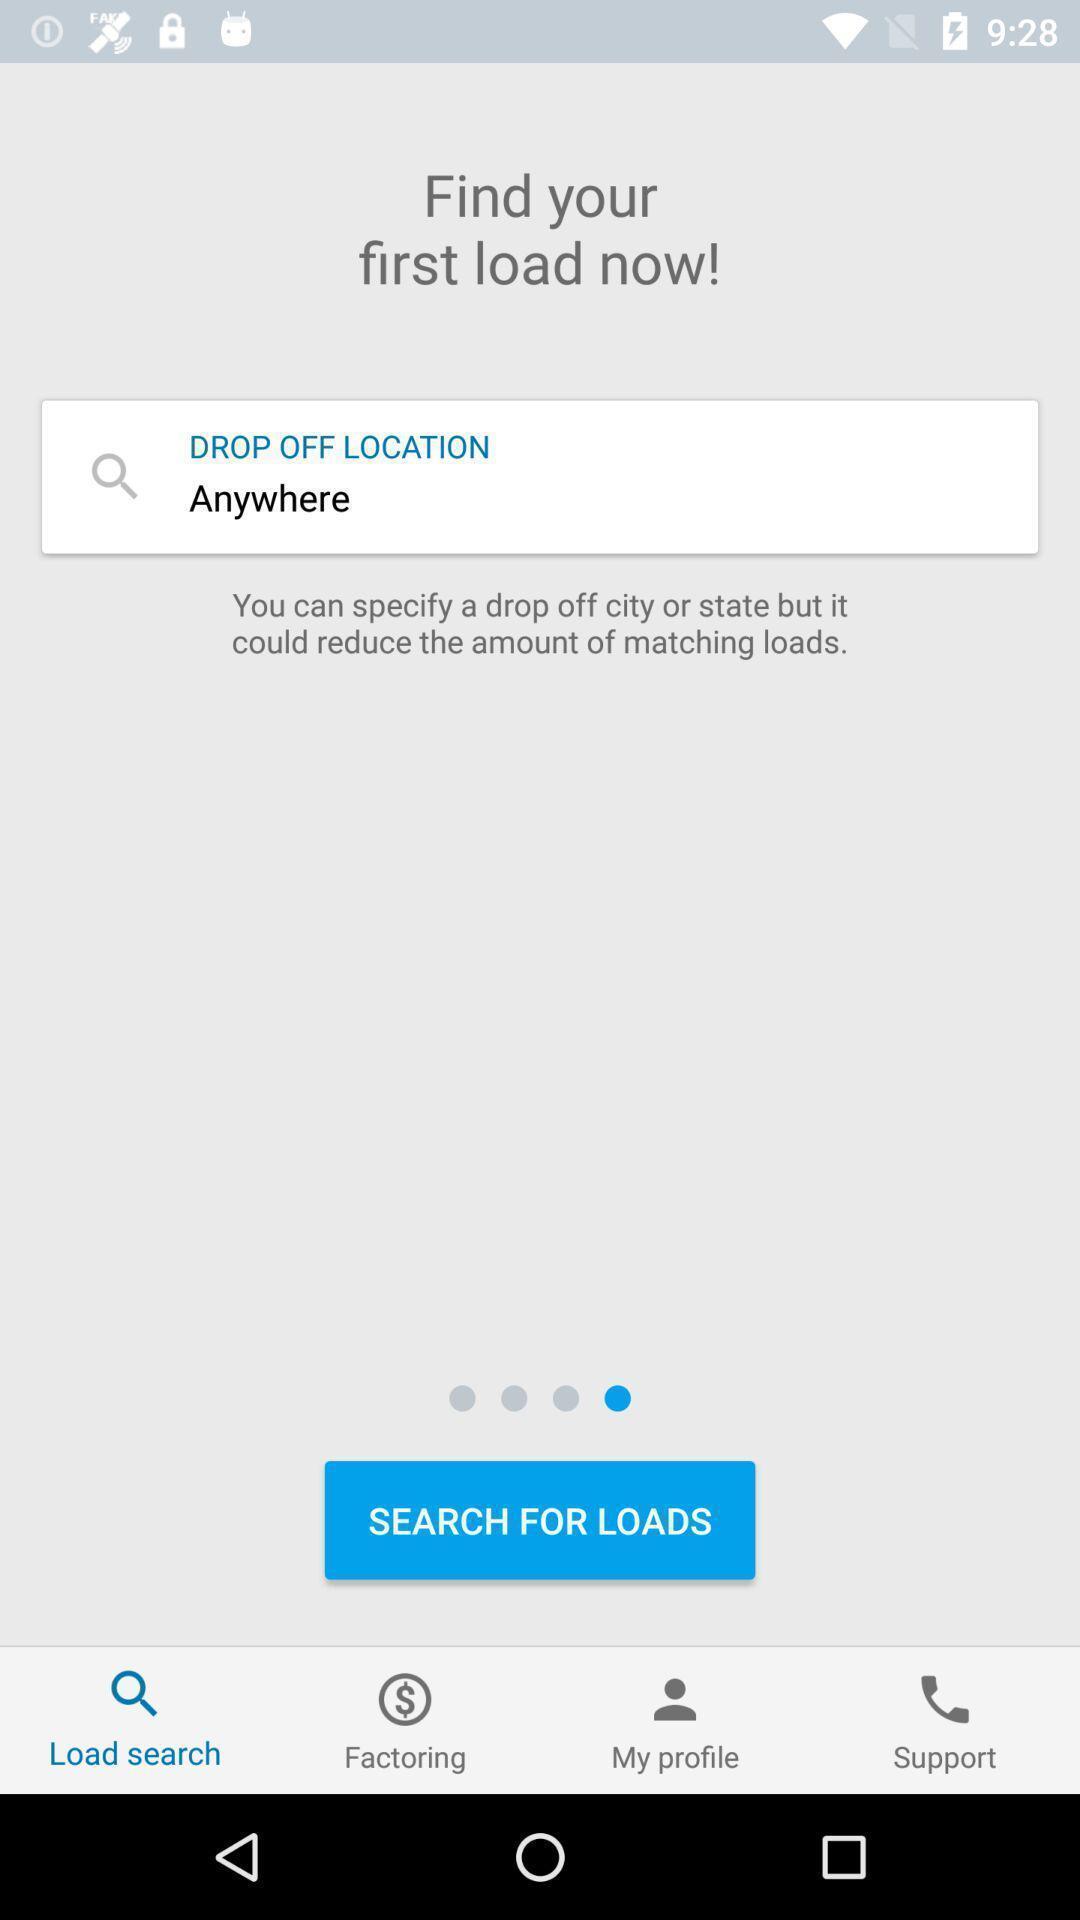Give me a summary of this screen capture. Screen displaying multiple options and search bar. 